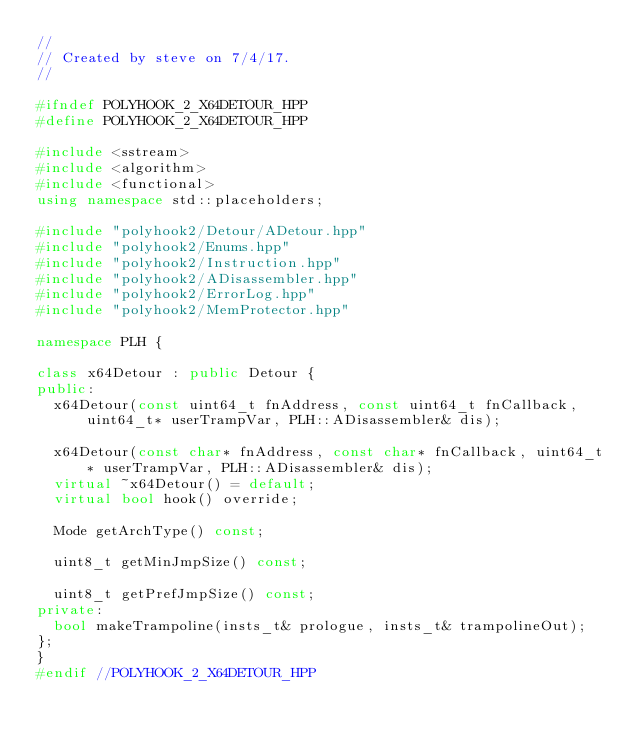<code> <loc_0><loc_0><loc_500><loc_500><_C++_>//
// Created by steve on 7/4/17.
//

#ifndef POLYHOOK_2_X64DETOUR_HPP
#define POLYHOOK_2_X64DETOUR_HPP

#include <sstream>
#include <algorithm>
#include <functional>
using namespace std::placeholders;

#include "polyhook2/Detour/ADetour.hpp"
#include "polyhook2/Enums.hpp"
#include "polyhook2/Instruction.hpp"
#include "polyhook2/ADisassembler.hpp"
#include "polyhook2/ErrorLog.hpp"
#include "polyhook2/MemProtector.hpp"

namespace PLH {

class x64Detour : public Detour {
public:
	x64Detour(const uint64_t fnAddress, const uint64_t fnCallback, uint64_t* userTrampVar, PLH::ADisassembler& dis);

	x64Detour(const char* fnAddress, const char* fnCallback, uint64_t* userTrampVar, PLH::ADisassembler& dis);
	virtual ~x64Detour() = default;
	virtual bool hook() override;

	Mode getArchType() const;

	uint8_t getMinJmpSize() const;

	uint8_t getPrefJmpSize() const;
private:
	bool makeTrampoline(insts_t& prologue, insts_t& trampolineOut);
};
}
#endif //POLYHOOK_2_X64DETOUR_HPP
</code> 